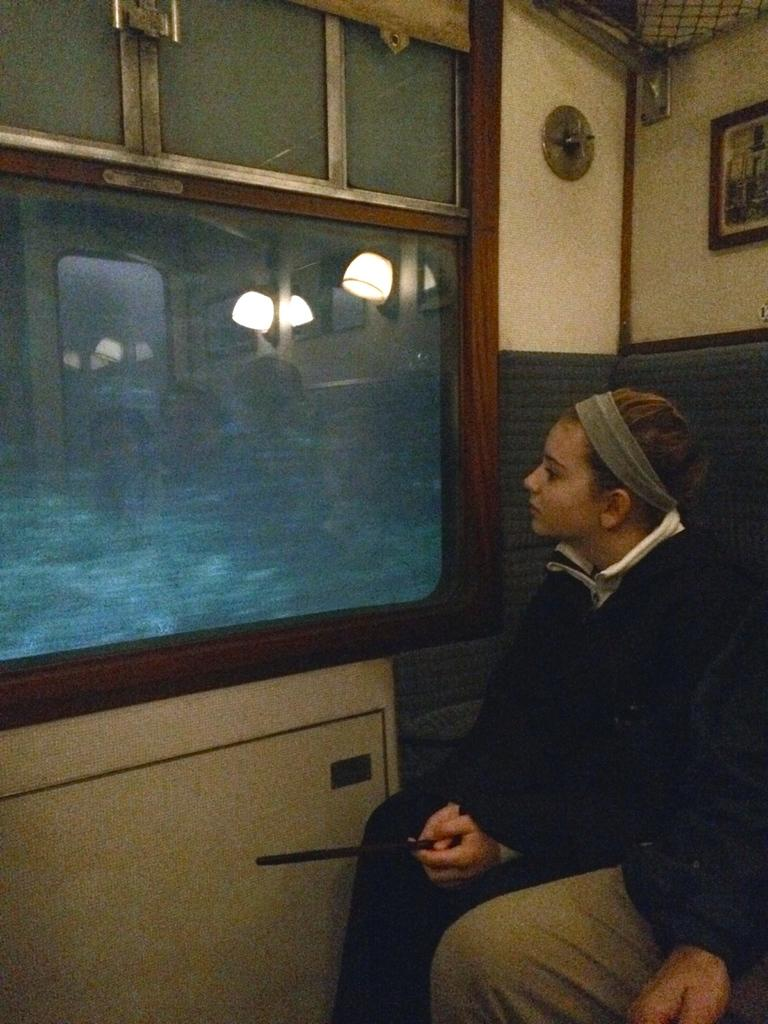How many people are present in the image? There are two persons seated in the image. What can be seen through the windows in the image? The windows are visible in the image, but the conversation does not provide information about what can be seen through them. What is on the wall in the background of the image? There is a wall frame on the wall in the background of the image. Where is the stove located in the image? There is no stove present in the image. What type of hole can be seen in the wall frame? There is no hole present in the wall frame or the image. 